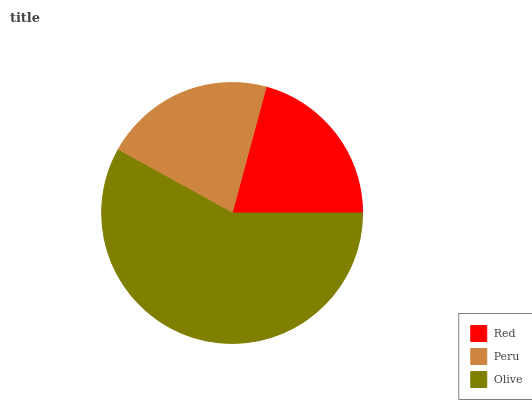Is Red the minimum?
Answer yes or no. Yes. Is Olive the maximum?
Answer yes or no. Yes. Is Peru the minimum?
Answer yes or no. No. Is Peru the maximum?
Answer yes or no. No. Is Peru greater than Red?
Answer yes or no. Yes. Is Red less than Peru?
Answer yes or no. Yes. Is Red greater than Peru?
Answer yes or no. No. Is Peru less than Red?
Answer yes or no. No. Is Peru the high median?
Answer yes or no. Yes. Is Peru the low median?
Answer yes or no. Yes. Is Red the high median?
Answer yes or no. No. Is Olive the low median?
Answer yes or no. No. 